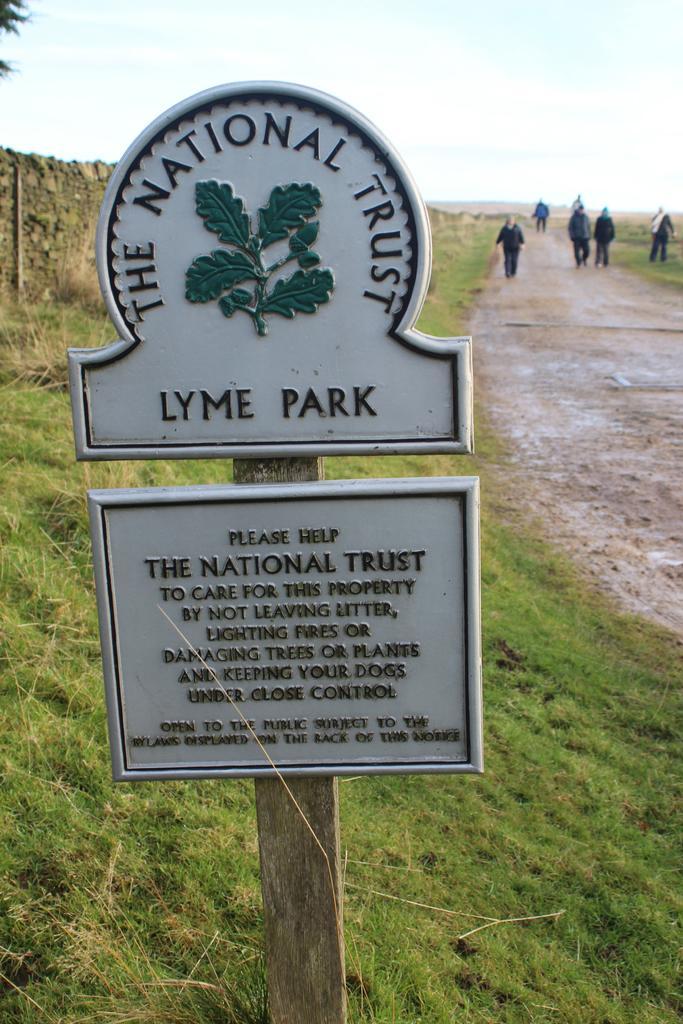In one or two sentences, can you explain what this image depicts? As we can see in the image there is a sign board, grass, wall, few people here and there and a sky. 